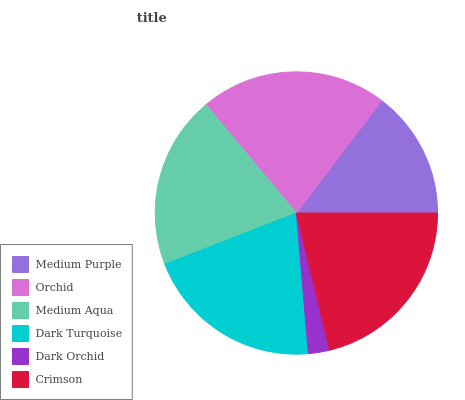Is Dark Orchid the minimum?
Answer yes or no. Yes. Is Orchid the maximum?
Answer yes or no. Yes. Is Medium Aqua the minimum?
Answer yes or no. No. Is Medium Aqua the maximum?
Answer yes or no. No. Is Orchid greater than Medium Aqua?
Answer yes or no. Yes. Is Medium Aqua less than Orchid?
Answer yes or no. Yes. Is Medium Aqua greater than Orchid?
Answer yes or no. No. Is Orchid less than Medium Aqua?
Answer yes or no. No. Is Dark Turquoise the high median?
Answer yes or no. Yes. Is Medium Aqua the low median?
Answer yes or no. Yes. Is Medium Aqua the high median?
Answer yes or no. No. Is Dark Turquoise the low median?
Answer yes or no. No. 